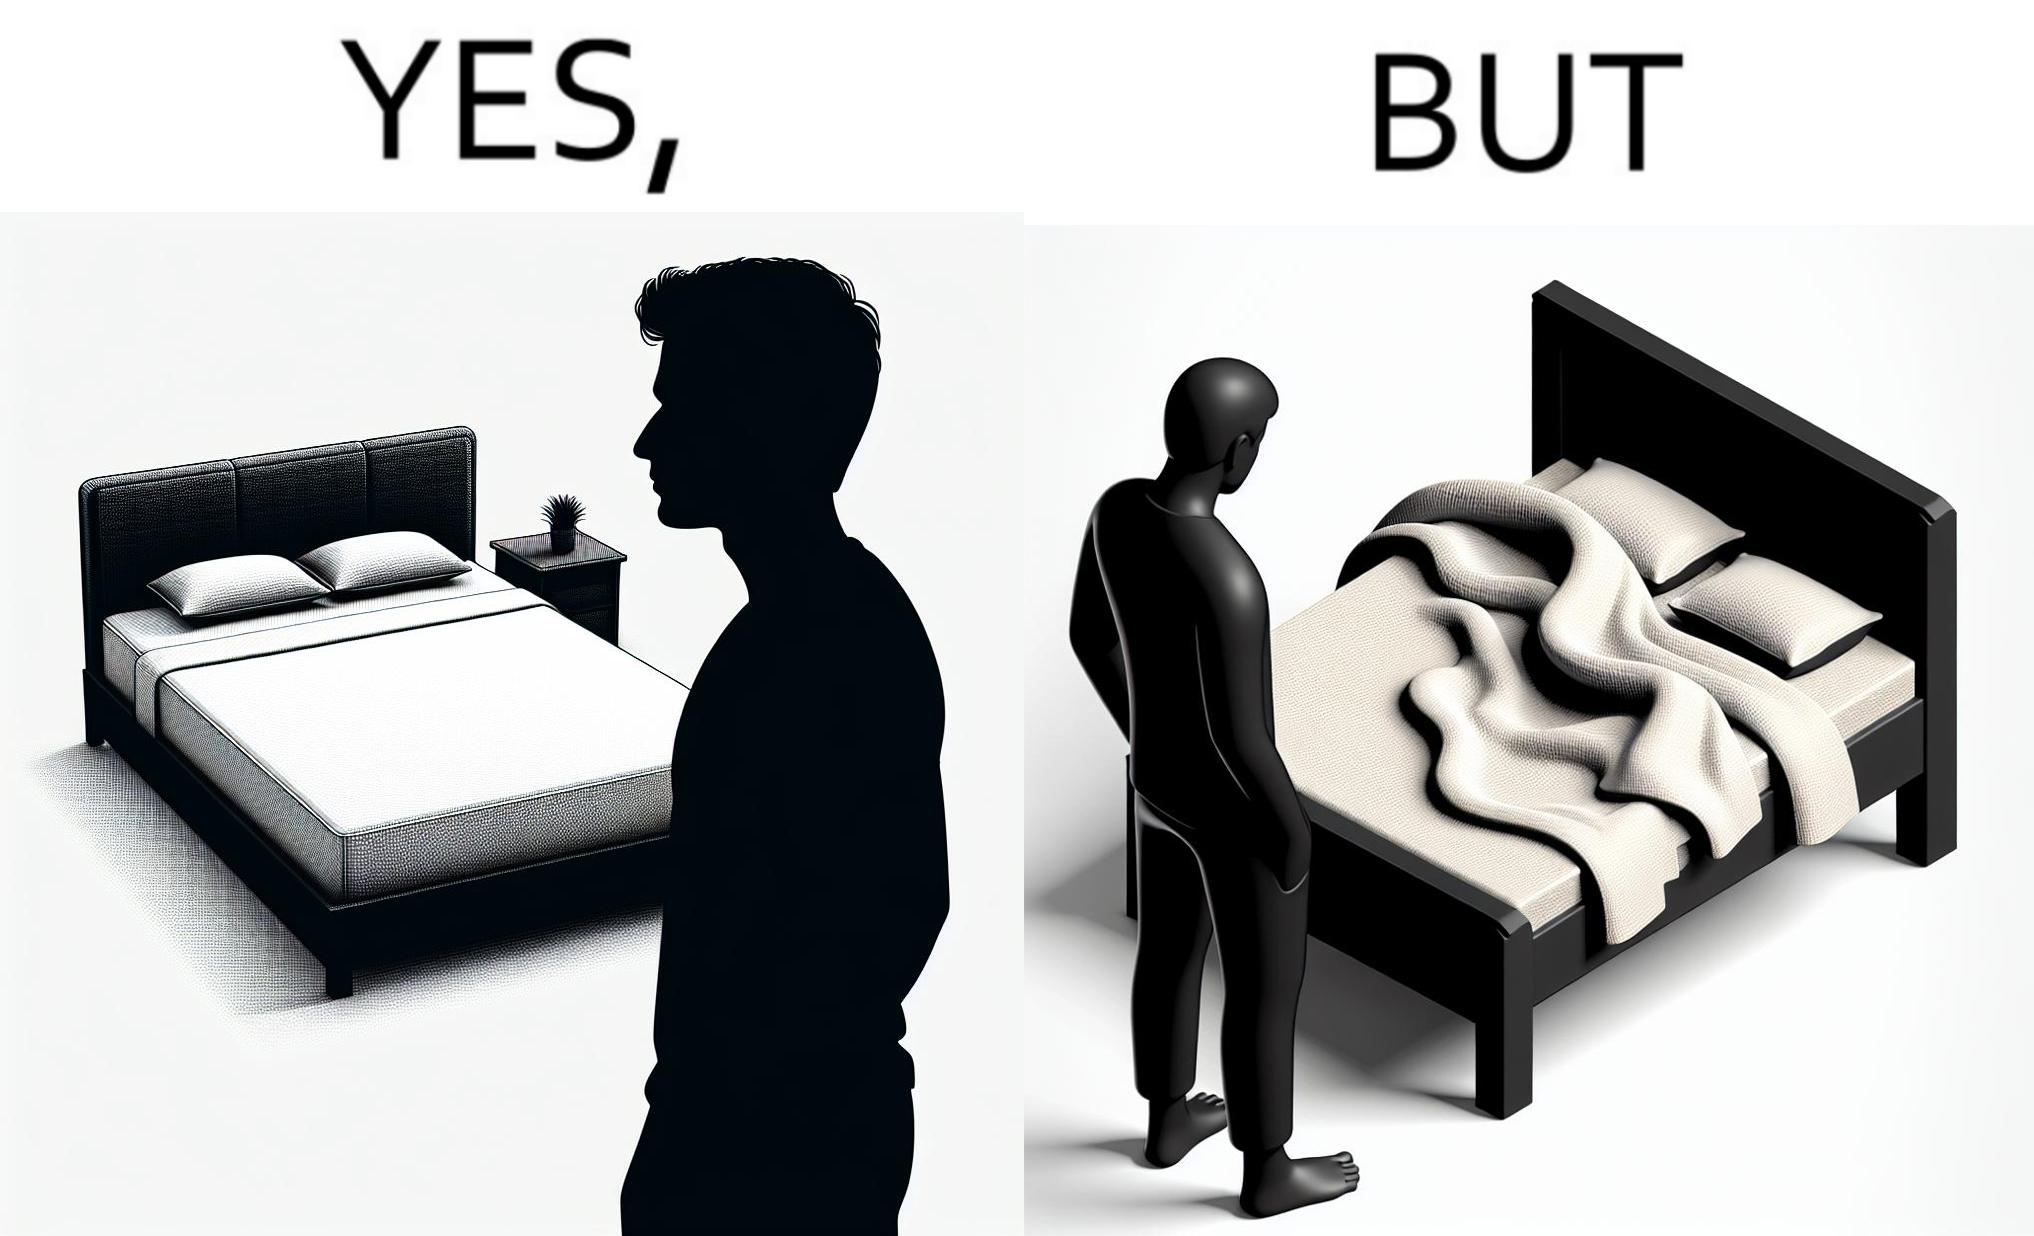Describe what you see in this image. The image is funny because while the bed seems to be well made with the blanket on top, the actual blanket inside the blanket cover is twisted and not properly set. 